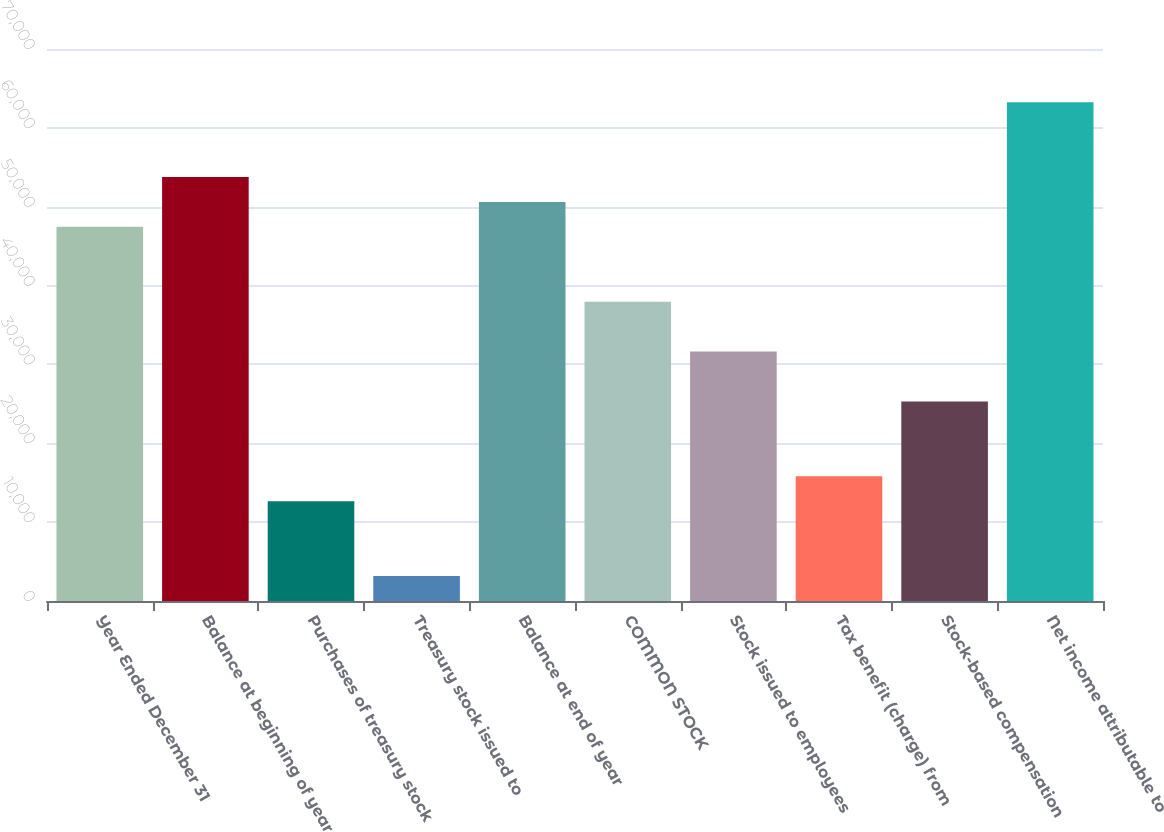Convert chart to OTSL. <chart><loc_0><loc_0><loc_500><loc_500><bar_chart><fcel>Year Ended December 31<fcel>Balance at beginning of year<fcel>Purchases of treasury stock<fcel>Treasury stock issued to<fcel>Balance at end of year<fcel>COMMON STOCK<fcel>Stock issued to employees<fcel>Tax benefit (charge) from<fcel>Stock-based compensation<fcel>Net income attributable to<nl><fcel>47449<fcel>53774.6<fcel>12658.2<fcel>3169.8<fcel>50611.8<fcel>37960.6<fcel>31635<fcel>15821<fcel>25309.4<fcel>63263<nl></chart> 